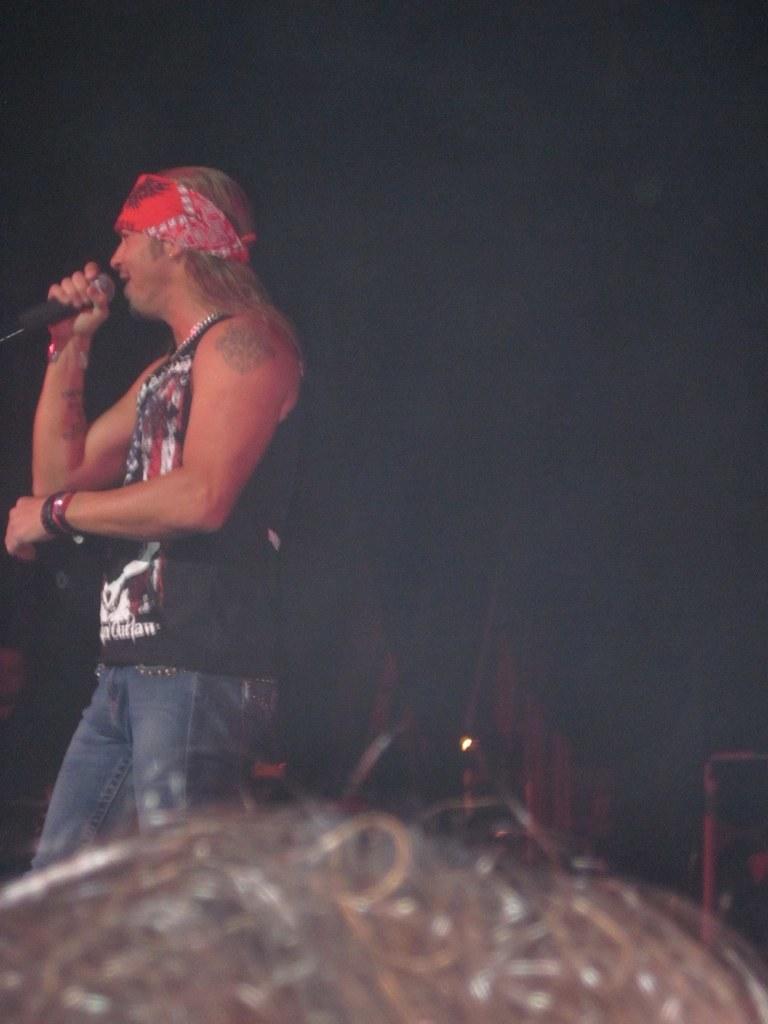Describe this image in one or two sentences. In this image a person holding a mike visible on , background is dark. 